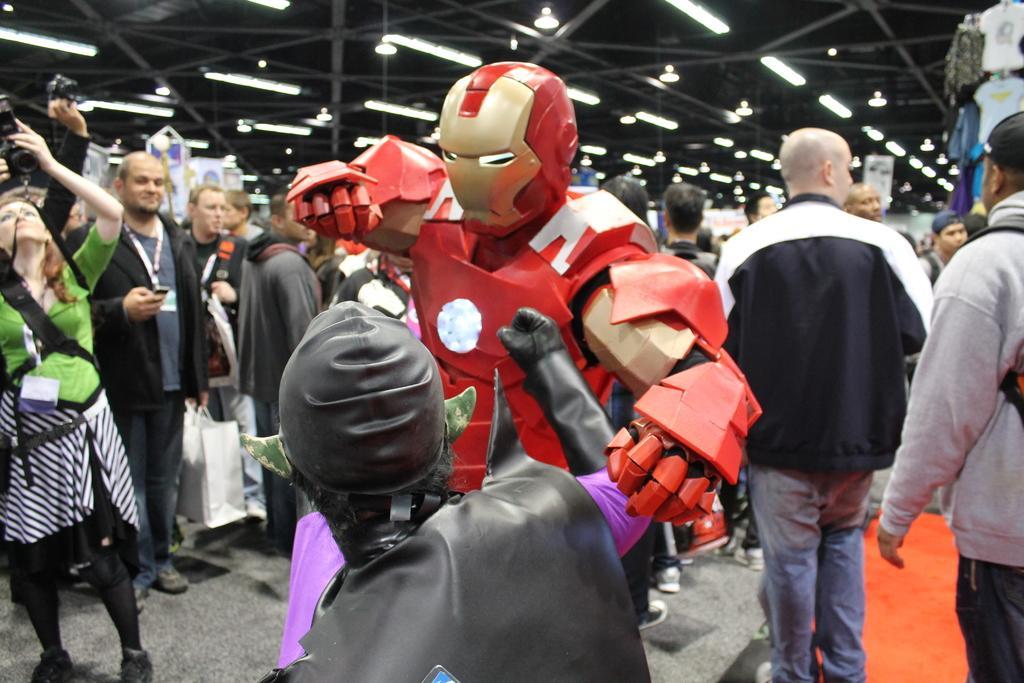Can you describe this image briefly? In this picture we can see there are two people in fancy dress and behind the people there are groups of people and two people are holding the cameras. There are ceiling lights on the top. 